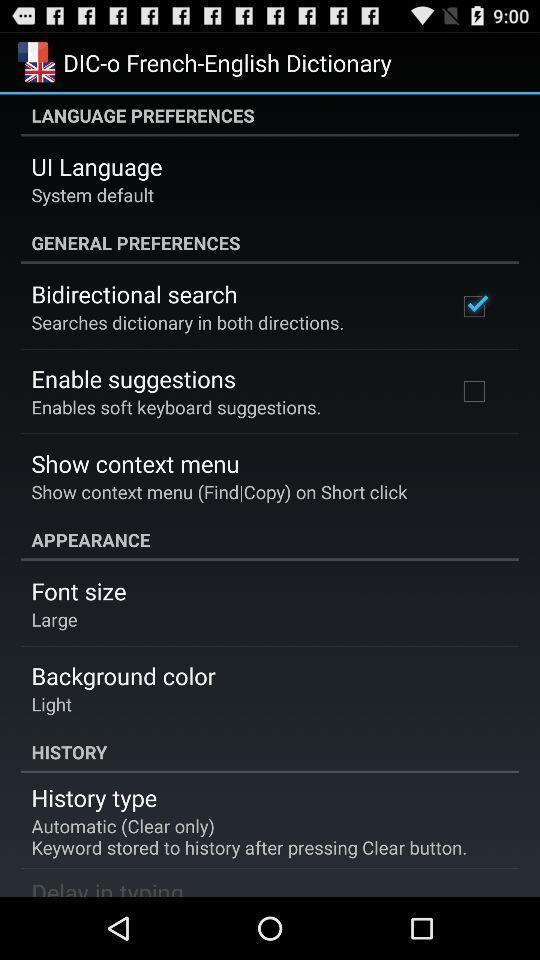Describe this image in words. Screen shows different options in dictionary app. 